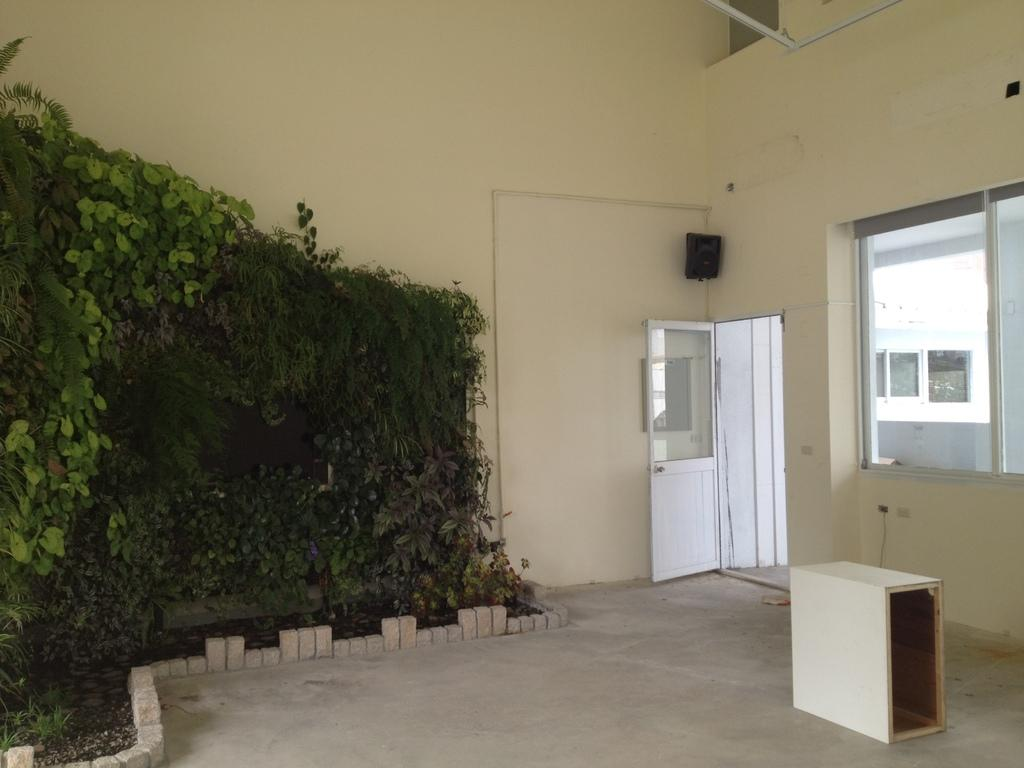What part of a building is shown in the image? The image shows the inner part of a room. What type of vegetation can be seen in the room? There are plants in the room, and they are green in color. What can be seen outside the room through the windows? Windows are visible in the background, but the image does not show what can be seen outside. What is the color of the door in the background? The door in the background is white in color. What is the color of the wall in the background? The wall in the background is cream-colored. Where is the nest of the bird located in the image? There is no nest or bird present in the image. What type of plough is being used to cultivate the plants in the image? There is no plough present in the image, as it is an indoor setting with plants in pots. 